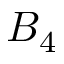Convert formula to latex. <formula><loc_0><loc_0><loc_500><loc_500>B _ { 4 }</formula> 